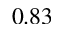<formula> <loc_0><loc_0><loc_500><loc_500>0 . 8 3</formula> 